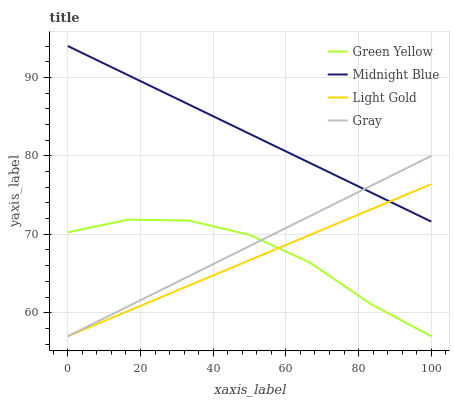Does Light Gold have the minimum area under the curve?
Answer yes or no. Yes. Does Midnight Blue have the maximum area under the curve?
Answer yes or no. Yes. Does Green Yellow have the minimum area under the curve?
Answer yes or no. No. Does Green Yellow have the maximum area under the curve?
Answer yes or no. No. Is Midnight Blue the smoothest?
Answer yes or no. Yes. Is Green Yellow the roughest?
Answer yes or no. Yes. Is Light Gold the smoothest?
Answer yes or no. No. Is Light Gold the roughest?
Answer yes or no. No. Does Gray have the lowest value?
Answer yes or no. Yes. Does Midnight Blue have the lowest value?
Answer yes or no. No. Does Midnight Blue have the highest value?
Answer yes or no. Yes. Does Light Gold have the highest value?
Answer yes or no. No. Is Green Yellow less than Midnight Blue?
Answer yes or no. Yes. Is Midnight Blue greater than Green Yellow?
Answer yes or no. Yes. Does Green Yellow intersect Light Gold?
Answer yes or no. Yes. Is Green Yellow less than Light Gold?
Answer yes or no. No. Is Green Yellow greater than Light Gold?
Answer yes or no. No. Does Green Yellow intersect Midnight Blue?
Answer yes or no. No. 